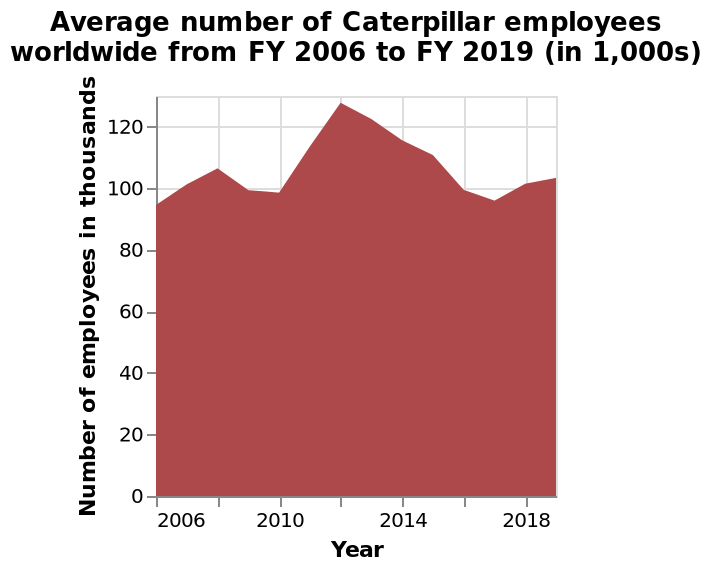<image>
In what unit is the number of employees represented? The number of employees is represented in thousands. How would you describe the overall trend of the number of employees from 2012 to 2018? The overall trend of the number of employees from 2012 to 2018 is a slow increase. What was the initial number of employees at the beginning of 2006? The description does not provide the specific initial number of employees at the beginning of 2006. What is being measured on the y-axis? The y-axis represents the number of employees in thousands. Did the number of employees increase or decrease from the beginning of 2006 to 2018?  The number of employees increased from the beginning of 2006 to 2018, with a slow increase over time. Is the overall trend of the number of employees from 2012 to 2018 a fast decrease? No.The overall trend of the number of employees from 2012 to 2018 is a slow increase. 